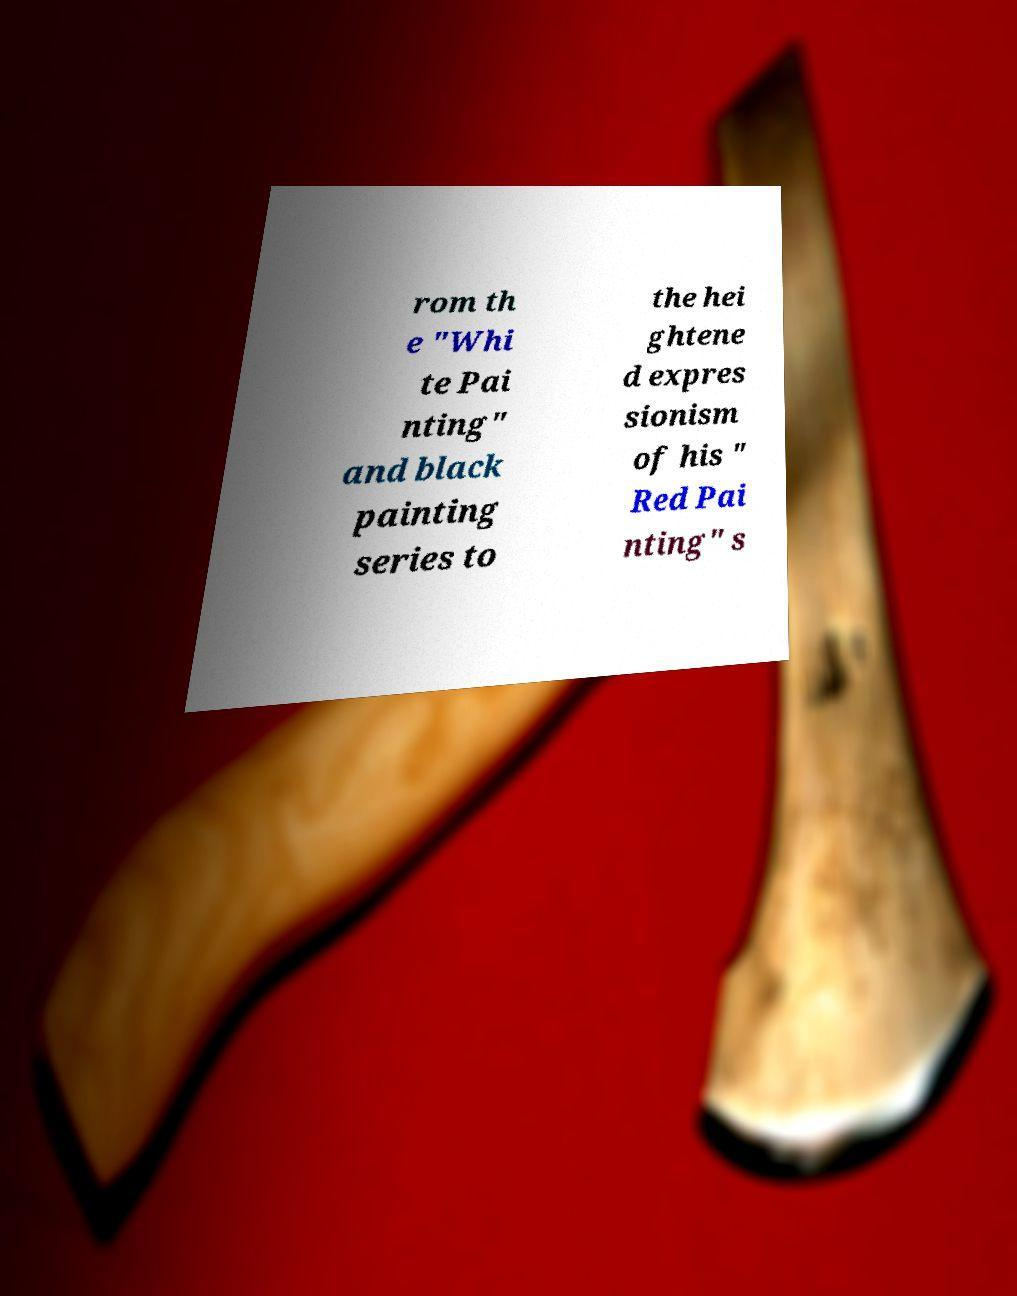Could you extract and type out the text from this image? rom th e "Whi te Pai nting" and black painting series to the hei ghtene d expres sionism of his " Red Pai nting" s 